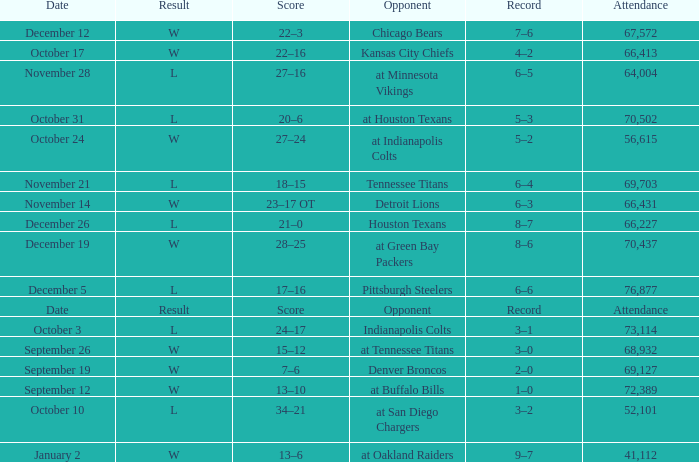What is the attendance when detroit lions are the opposing team? 66431.0. 